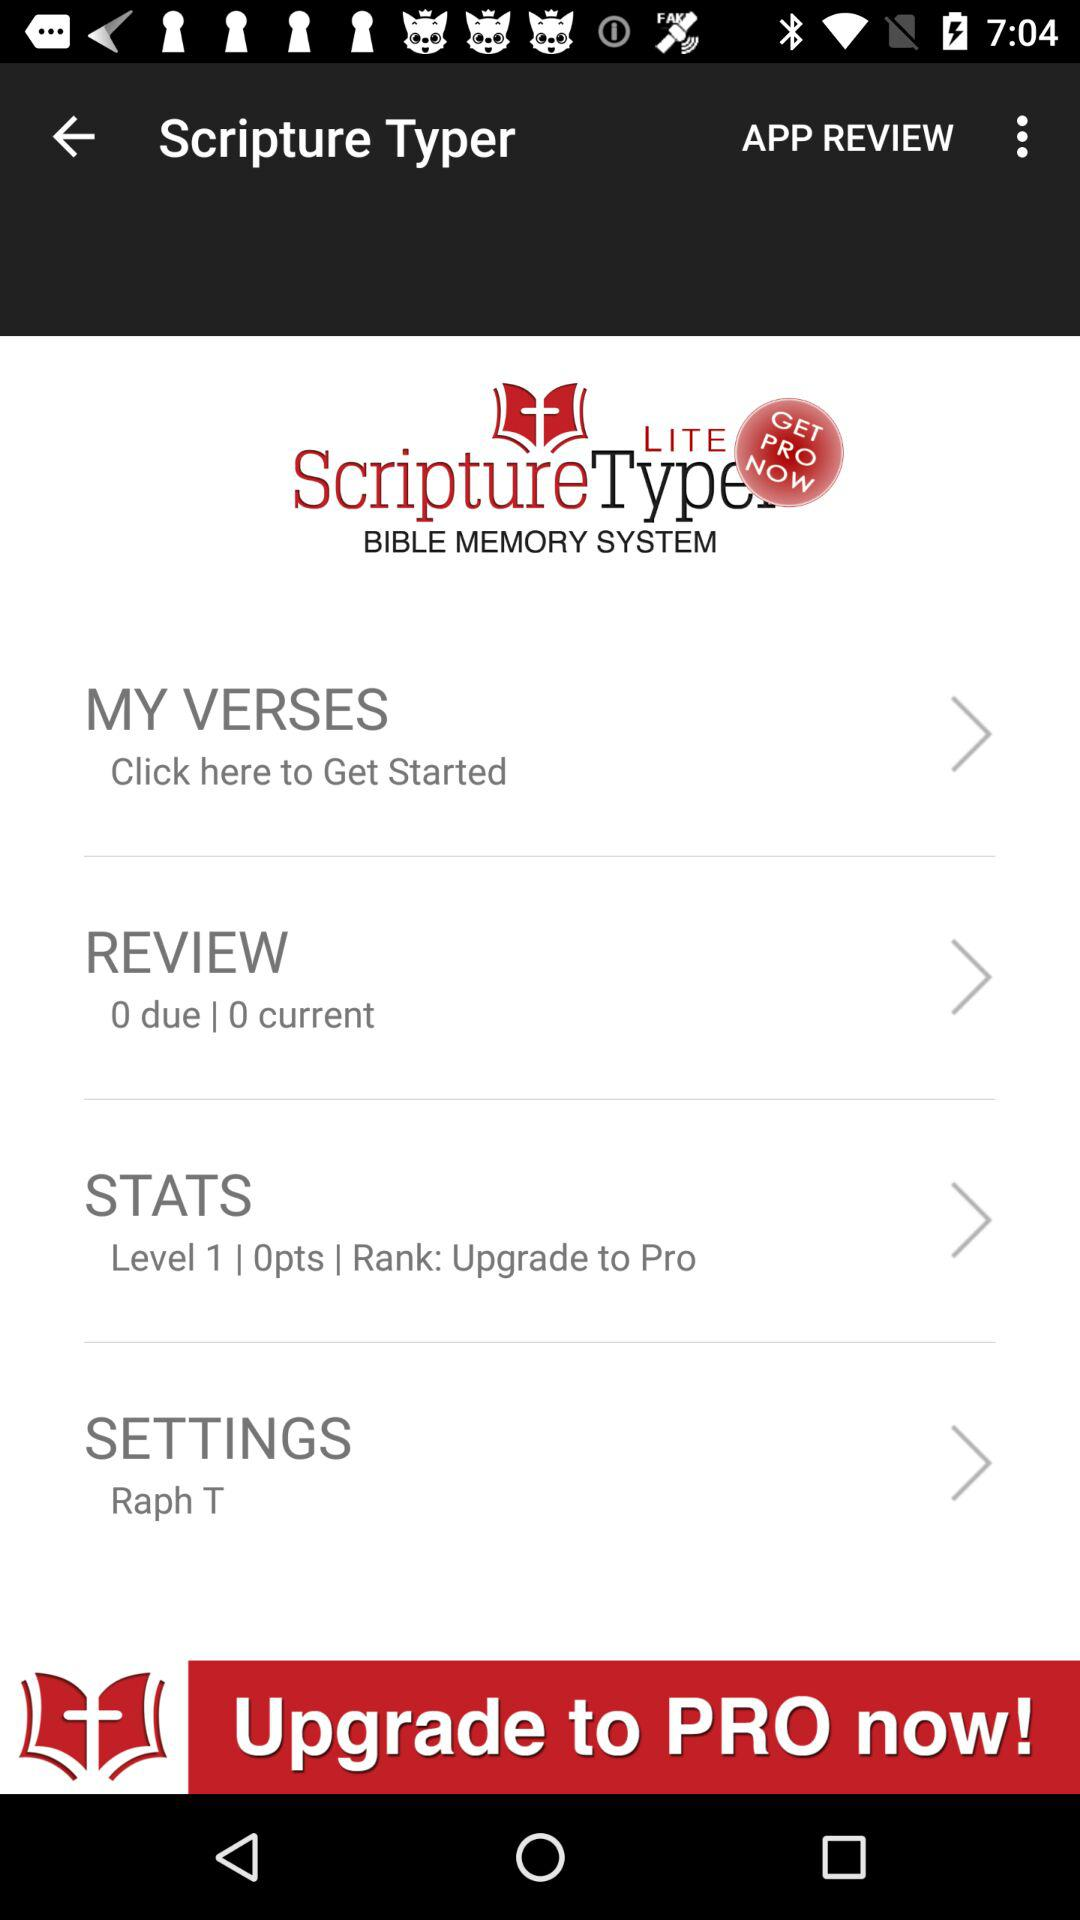What is the count of due review? The count is 0. 